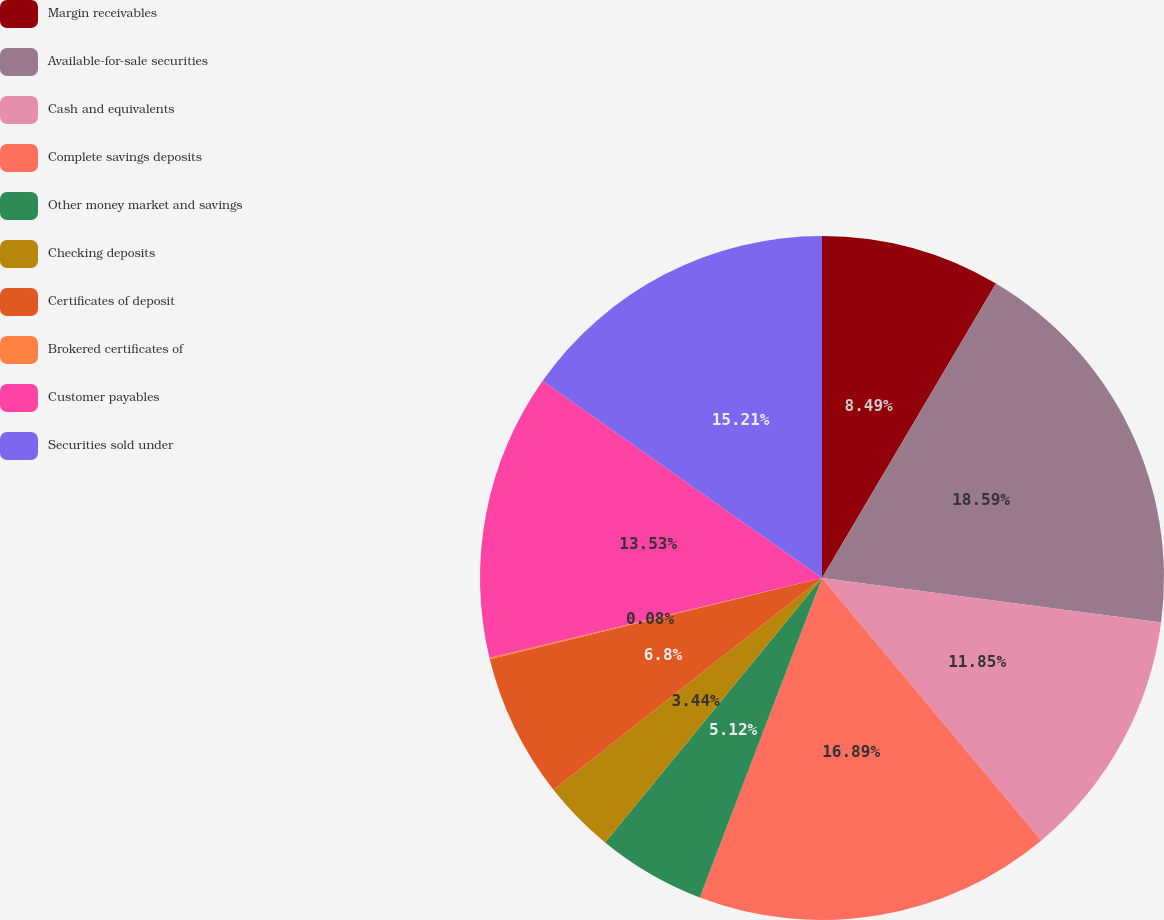<chart> <loc_0><loc_0><loc_500><loc_500><pie_chart><fcel>Margin receivables<fcel>Available-for-sale securities<fcel>Cash and equivalents<fcel>Complete savings deposits<fcel>Other money market and savings<fcel>Checking deposits<fcel>Certificates of deposit<fcel>Brokered certificates of<fcel>Customer payables<fcel>Securities sold under<nl><fcel>8.49%<fcel>18.58%<fcel>11.85%<fcel>16.89%<fcel>5.12%<fcel>3.44%<fcel>6.8%<fcel>0.08%<fcel>13.53%<fcel>15.21%<nl></chart> 